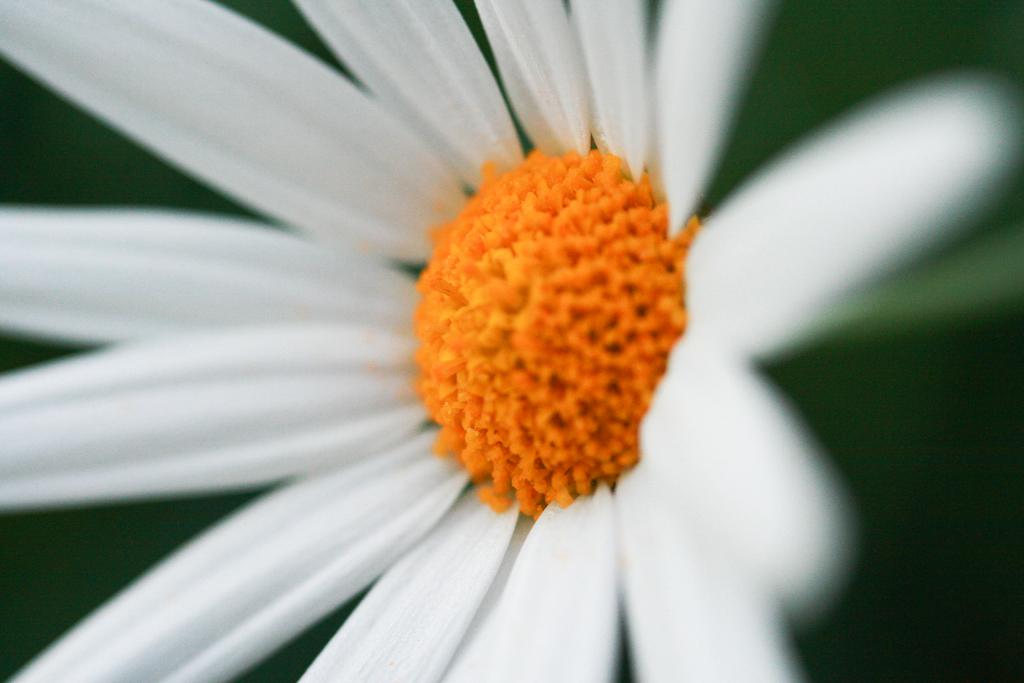What is the main subject of the image? There is a flower in the image. Can you describe the colors of the flower? The flower has white and yellow colors. How would you describe the background of the image? The background of the image is blurred. How many chairs can be seen in the image? There are no chairs present in the image; it features a flower with a blurred background. What type of apple is depicted in the image? There is no apple present in the image; it features a flower with a blurred background. 